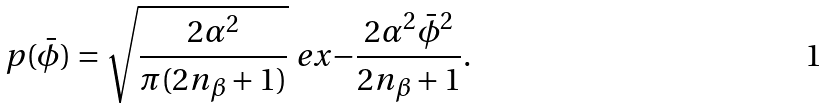Convert formula to latex. <formula><loc_0><loc_0><loc_500><loc_500>p ( \bar { \phi } ) = \sqrt { \frac { 2 \alpha ^ { 2 } } { \pi ( 2 n _ { \beta } + 1 ) } } \ e x { - \frac { 2 \alpha ^ { 2 } \bar { \phi } ^ { 2 } } { 2 n _ { \beta } + 1 } } .</formula> 